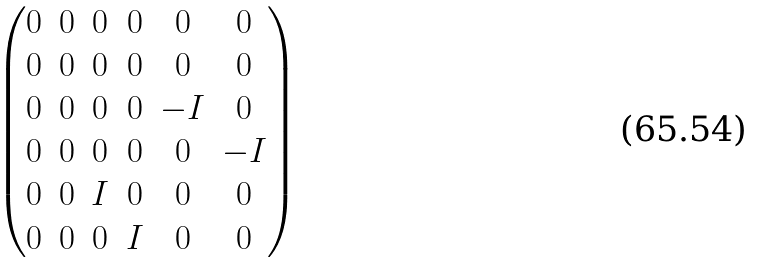Convert formula to latex. <formula><loc_0><loc_0><loc_500><loc_500>\begin{pmatrix} { 0 } & 0 & 0 & 0 & 0 & 0 \\ { 0 } & 0 & 0 & 0 & 0 & 0 \\ { 0 } & 0 & 0 & 0 & - I & 0 \\ { 0 } & 0 & 0 & 0 & 0 & - I \\ { 0 } & 0 & I & 0 & 0 & 0 \\ { 0 } & 0 & 0 & I & 0 & 0 \end{pmatrix}</formula> 